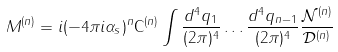<formula> <loc_0><loc_0><loc_500><loc_500>M ^ { ( n ) } = i ( - 4 \pi i \alpha _ { s } ) ^ { n } \mathsf C ^ { ( n ) } \int \frac { d ^ { 4 } q _ { 1 } } { ( 2 \pi ) ^ { 4 } } \dots \frac { d ^ { 4 } q _ { n - 1 } } { ( 2 \pi ) ^ { 4 } } \frac { \mathcal { N } ^ { ( n ) } } { \mathcal { D } ^ { ( n ) } }</formula> 